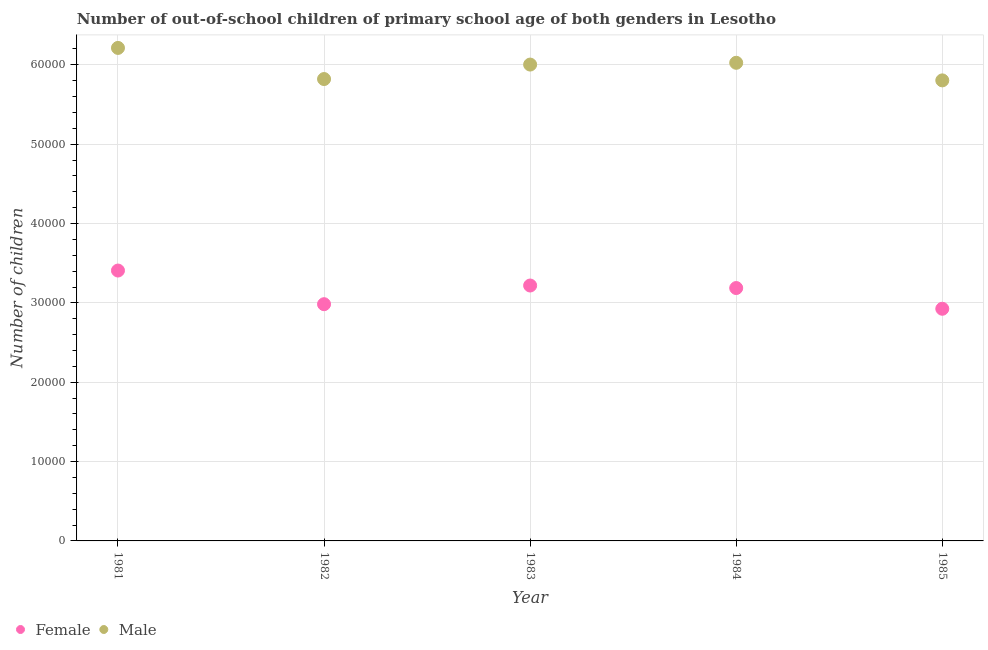How many different coloured dotlines are there?
Your answer should be very brief. 2. Is the number of dotlines equal to the number of legend labels?
Give a very brief answer. Yes. What is the number of male out-of-school students in 1984?
Keep it short and to the point. 6.03e+04. Across all years, what is the maximum number of female out-of-school students?
Make the answer very short. 3.41e+04. Across all years, what is the minimum number of female out-of-school students?
Offer a terse response. 2.93e+04. In which year was the number of female out-of-school students maximum?
Offer a terse response. 1981. What is the total number of female out-of-school students in the graph?
Provide a short and direct response. 1.57e+05. What is the difference between the number of male out-of-school students in 1982 and that in 1984?
Offer a terse response. -2048. What is the difference between the number of male out-of-school students in 1985 and the number of female out-of-school students in 1983?
Offer a very short reply. 2.59e+04. What is the average number of female out-of-school students per year?
Your answer should be compact. 3.14e+04. In the year 1982, what is the difference between the number of male out-of-school students and number of female out-of-school students?
Make the answer very short. 2.84e+04. In how many years, is the number of female out-of-school students greater than 30000?
Make the answer very short. 3. What is the ratio of the number of male out-of-school students in 1981 to that in 1982?
Your answer should be very brief. 1.07. Is the number of male out-of-school students in 1982 less than that in 1984?
Keep it short and to the point. Yes. Is the difference between the number of female out-of-school students in 1983 and 1984 greater than the difference between the number of male out-of-school students in 1983 and 1984?
Offer a terse response. Yes. What is the difference between the highest and the second highest number of female out-of-school students?
Give a very brief answer. 1887. What is the difference between the highest and the lowest number of female out-of-school students?
Your answer should be compact. 4817. In how many years, is the number of male out-of-school students greater than the average number of male out-of-school students taken over all years?
Keep it short and to the point. 3. Is the sum of the number of male out-of-school students in 1983 and 1984 greater than the maximum number of female out-of-school students across all years?
Provide a short and direct response. Yes. Are the values on the major ticks of Y-axis written in scientific E-notation?
Your answer should be very brief. No. Does the graph contain any zero values?
Your answer should be compact. No. Where does the legend appear in the graph?
Offer a terse response. Bottom left. How many legend labels are there?
Provide a succinct answer. 2. What is the title of the graph?
Keep it short and to the point. Number of out-of-school children of primary school age of both genders in Lesotho. Does "Electricity" appear as one of the legend labels in the graph?
Provide a succinct answer. No. What is the label or title of the Y-axis?
Your response must be concise. Number of children. What is the Number of children of Female in 1981?
Your answer should be very brief. 3.41e+04. What is the Number of children in Male in 1981?
Provide a short and direct response. 6.21e+04. What is the Number of children in Female in 1982?
Offer a terse response. 2.98e+04. What is the Number of children of Male in 1982?
Your answer should be very brief. 5.82e+04. What is the Number of children of Female in 1983?
Your answer should be compact. 3.22e+04. What is the Number of children of Male in 1983?
Your answer should be compact. 6.00e+04. What is the Number of children of Female in 1984?
Offer a terse response. 3.19e+04. What is the Number of children in Male in 1984?
Your answer should be very brief. 6.03e+04. What is the Number of children in Female in 1985?
Provide a succinct answer. 2.93e+04. What is the Number of children of Male in 1985?
Give a very brief answer. 5.80e+04. Across all years, what is the maximum Number of children of Female?
Offer a terse response. 3.41e+04. Across all years, what is the maximum Number of children in Male?
Your answer should be very brief. 6.21e+04. Across all years, what is the minimum Number of children in Female?
Ensure brevity in your answer.  2.93e+04. Across all years, what is the minimum Number of children in Male?
Offer a terse response. 5.80e+04. What is the total Number of children of Female in the graph?
Provide a succinct answer. 1.57e+05. What is the total Number of children in Male in the graph?
Keep it short and to the point. 2.99e+05. What is the difference between the Number of children in Female in 1981 and that in 1982?
Give a very brief answer. 4241. What is the difference between the Number of children of Male in 1981 and that in 1982?
Provide a succinct answer. 3923. What is the difference between the Number of children of Female in 1981 and that in 1983?
Offer a terse response. 1887. What is the difference between the Number of children in Male in 1981 and that in 1983?
Give a very brief answer. 2099. What is the difference between the Number of children in Female in 1981 and that in 1984?
Give a very brief answer. 2205. What is the difference between the Number of children in Male in 1981 and that in 1984?
Your answer should be very brief. 1875. What is the difference between the Number of children of Female in 1981 and that in 1985?
Your response must be concise. 4817. What is the difference between the Number of children in Male in 1981 and that in 1985?
Keep it short and to the point. 4092. What is the difference between the Number of children of Female in 1982 and that in 1983?
Your answer should be very brief. -2354. What is the difference between the Number of children of Male in 1982 and that in 1983?
Give a very brief answer. -1824. What is the difference between the Number of children in Female in 1982 and that in 1984?
Keep it short and to the point. -2036. What is the difference between the Number of children in Male in 1982 and that in 1984?
Ensure brevity in your answer.  -2048. What is the difference between the Number of children of Female in 1982 and that in 1985?
Your response must be concise. 576. What is the difference between the Number of children in Male in 1982 and that in 1985?
Your answer should be very brief. 169. What is the difference between the Number of children of Female in 1983 and that in 1984?
Provide a short and direct response. 318. What is the difference between the Number of children in Male in 1983 and that in 1984?
Make the answer very short. -224. What is the difference between the Number of children in Female in 1983 and that in 1985?
Provide a succinct answer. 2930. What is the difference between the Number of children of Male in 1983 and that in 1985?
Provide a succinct answer. 1993. What is the difference between the Number of children in Female in 1984 and that in 1985?
Offer a terse response. 2612. What is the difference between the Number of children of Male in 1984 and that in 1985?
Your answer should be very brief. 2217. What is the difference between the Number of children in Female in 1981 and the Number of children in Male in 1982?
Your response must be concise. -2.41e+04. What is the difference between the Number of children of Female in 1981 and the Number of children of Male in 1983?
Your answer should be compact. -2.60e+04. What is the difference between the Number of children in Female in 1981 and the Number of children in Male in 1984?
Your answer should be compact. -2.62e+04. What is the difference between the Number of children of Female in 1981 and the Number of children of Male in 1985?
Offer a very short reply. -2.40e+04. What is the difference between the Number of children in Female in 1982 and the Number of children in Male in 1983?
Provide a succinct answer. -3.02e+04. What is the difference between the Number of children of Female in 1982 and the Number of children of Male in 1984?
Your answer should be compact. -3.04e+04. What is the difference between the Number of children in Female in 1982 and the Number of children in Male in 1985?
Your response must be concise. -2.82e+04. What is the difference between the Number of children of Female in 1983 and the Number of children of Male in 1984?
Give a very brief answer. -2.81e+04. What is the difference between the Number of children in Female in 1983 and the Number of children in Male in 1985?
Your answer should be compact. -2.59e+04. What is the difference between the Number of children in Female in 1984 and the Number of children in Male in 1985?
Your answer should be very brief. -2.62e+04. What is the average Number of children of Female per year?
Ensure brevity in your answer.  3.14e+04. What is the average Number of children in Male per year?
Give a very brief answer. 5.97e+04. In the year 1981, what is the difference between the Number of children in Female and Number of children in Male?
Offer a terse response. -2.81e+04. In the year 1982, what is the difference between the Number of children in Female and Number of children in Male?
Offer a terse response. -2.84e+04. In the year 1983, what is the difference between the Number of children of Female and Number of children of Male?
Your response must be concise. -2.78e+04. In the year 1984, what is the difference between the Number of children of Female and Number of children of Male?
Your response must be concise. -2.84e+04. In the year 1985, what is the difference between the Number of children in Female and Number of children in Male?
Provide a short and direct response. -2.88e+04. What is the ratio of the Number of children of Female in 1981 to that in 1982?
Offer a very short reply. 1.14. What is the ratio of the Number of children in Male in 1981 to that in 1982?
Offer a very short reply. 1.07. What is the ratio of the Number of children of Female in 1981 to that in 1983?
Provide a succinct answer. 1.06. What is the ratio of the Number of children in Male in 1981 to that in 1983?
Give a very brief answer. 1.03. What is the ratio of the Number of children of Female in 1981 to that in 1984?
Your answer should be very brief. 1.07. What is the ratio of the Number of children in Male in 1981 to that in 1984?
Your answer should be compact. 1.03. What is the ratio of the Number of children of Female in 1981 to that in 1985?
Give a very brief answer. 1.16. What is the ratio of the Number of children of Male in 1981 to that in 1985?
Offer a very short reply. 1.07. What is the ratio of the Number of children of Female in 1982 to that in 1983?
Make the answer very short. 0.93. What is the ratio of the Number of children in Male in 1982 to that in 1983?
Make the answer very short. 0.97. What is the ratio of the Number of children in Female in 1982 to that in 1984?
Your answer should be compact. 0.94. What is the ratio of the Number of children in Female in 1982 to that in 1985?
Your answer should be compact. 1.02. What is the ratio of the Number of children of Male in 1982 to that in 1985?
Your answer should be compact. 1. What is the ratio of the Number of children of Male in 1983 to that in 1984?
Offer a terse response. 1. What is the ratio of the Number of children in Female in 1983 to that in 1985?
Your answer should be very brief. 1.1. What is the ratio of the Number of children of Male in 1983 to that in 1985?
Offer a very short reply. 1.03. What is the ratio of the Number of children in Female in 1984 to that in 1985?
Provide a succinct answer. 1.09. What is the ratio of the Number of children of Male in 1984 to that in 1985?
Make the answer very short. 1.04. What is the difference between the highest and the second highest Number of children of Female?
Provide a succinct answer. 1887. What is the difference between the highest and the second highest Number of children of Male?
Offer a terse response. 1875. What is the difference between the highest and the lowest Number of children in Female?
Provide a short and direct response. 4817. What is the difference between the highest and the lowest Number of children of Male?
Provide a short and direct response. 4092. 